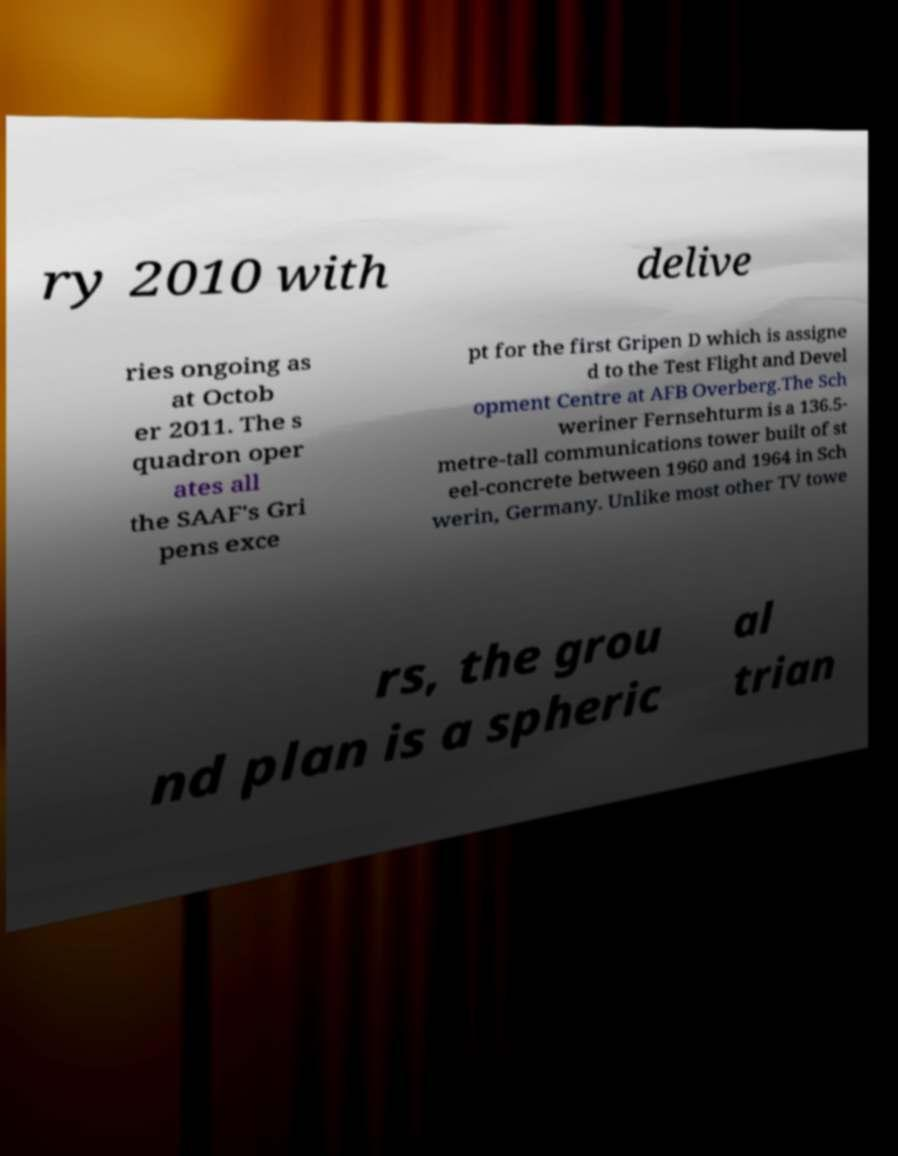What messages or text are displayed in this image? I need them in a readable, typed format. ry 2010 with delive ries ongoing as at Octob er 2011. The s quadron oper ates all the SAAF's Gri pens exce pt for the first Gripen D which is assigne d to the Test Flight and Devel opment Centre at AFB Overberg.The Sch weriner Fernsehturm is a 136.5- metre-tall communications tower built of st eel-concrete between 1960 and 1964 in Sch werin, Germany. Unlike most other TV towe rs, the grou nd plan is a spheric al trian 